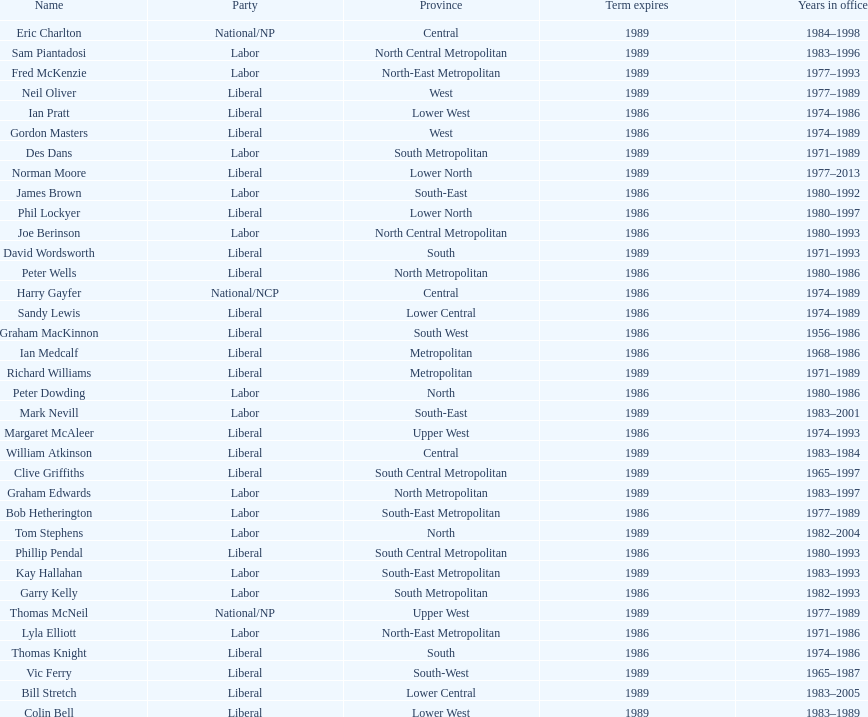Which party has the most membership? Liberal. 